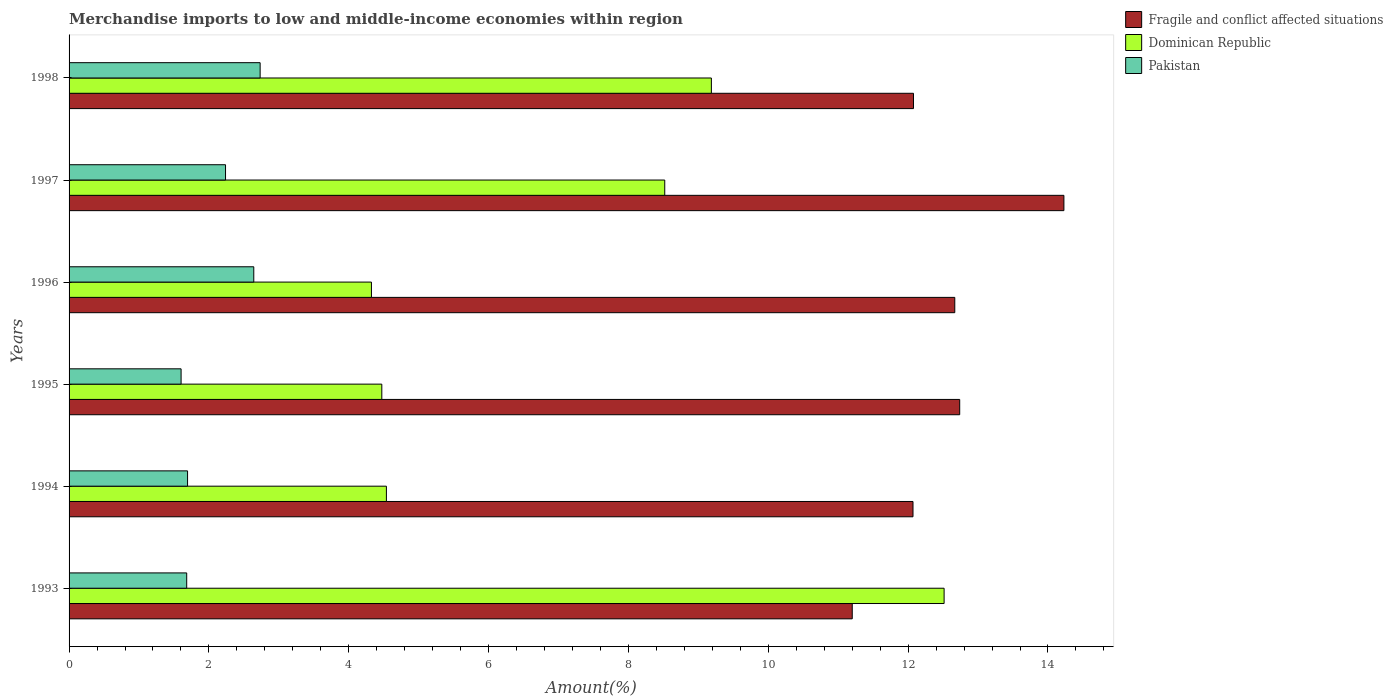How many different coloured bars are there?
Your answer should be very brief. 3. How many groups of bars are there?
Ensure brevity in your answer.  6. Are the number of bars per tick equal to the number of legend labels?
Ensure brevity in your answer.  Yes. Are the number of bars on each tick of the Y-axis equal?
Ensure brevity in your answer.  Yes. What is the percentage of amount earned from merchandise imports in Pakistan in 1993?
Your response must be concise. 1.68. Across all years, what is the maximum percentage of amount earned from merchandise imports in Pakistan?
Offer a terse response. 2.73. Across all years, what is the minimum percentage of amount earned from merchandise imports in Dominican Republic?
Ensure brevity in your answer.  4.32. In which year was the percentage of amount earned from merchandise imports in Fragile and conflict affected situations maximum?
Make the answer very short. 1997. What is the total percentage of amount earned from merchandise imports in Dominican Republic in the graph?
Your answer should be very brief. 43.56. What is the difference between the percentage of amount earned from merchandise imports in Dominican Republic in 1994 and that in 1995?
Provide a succinct answer. 0.07. What is the difference between the percentage of amount earned from merchandise imports in Dominican Republic in 1995 and the percentage of amount earned from merchandise imports in Pakistan in 1997?
Keep it short and to the point. 2.23. What is the average percentage of amount earned from merchandise imports in Fragile and conflict affected situations per year?
Offer a very short reply. 12.5. In the year 1998, what is the difference between the percentage of amount earned from merchandise imports in Dominican Republic and percentage of amount earned from merchandise imports in Fragile and conflict affected situations?
Offer a very short reply. -2.89. What is the ratio of the percentage of amount earned from merchandise imports in Dominican Republic in 1995 to that in 1996?
Provide a short and direct response. 1.03. Is the percentage of amount earned from merchandise imports in Dominican Republic in 1993 less than that in 1996?
Your answer should be very brief. No. Is the difference between the percentage of amount earned from merchandise imports in Dominican Republic in 1993 and 1995 greater than the difference between the percentage of amount earned from merchandise imports in Fragile and conflict affected situations in 1993 and 1995?
Offer a terse response. Yes. What is the difference between the highest and the second highest percentage of amount earned from merchandise imports in Dominican Republic?
Keep it short and to the point. 3.33. What is the difference between the highest and the lowest percentage of amount earned from merchandise imports in Fragile and conflict affected situations?
Your answer should be compact. 3.03. Is the sum of the percentage of amount earned from merchandise imports in Fragile and conflict affected situations in 1994 and 1995 greater than the maximum percentage of amount earned from merchandise imports in Pakistan across all years?
Make the answer very short. Yes. What does the 3rd bar from the top in 1994 represents?
Your answer should be compact. Fragile and conflict affected situations. What does the 3rd bar from the bottom in 1997 represents?
Provide a succinct answer. Pakistan. Are all the bars in the graph horizontal?
Give a very brief answer. Yes. What is the difference between two consecutive major ticks on the X-axis?
Your answer should be very brief. 2. Are the values on the major ticks of X-axis written in scientific E-notation?
Ensure brevity in your answer.  No. Does the graph contain grids?
Offer a terse response. No. Where does the legend appear in the graph?
Keep it short and to the point. Top right. How many legend labels are there?
Ensure brevity in your answer.  3. What is the title of the graph?
Keep it short and to the point. Merchandise imports to low and middle-income economies within region. What is the label or title of the X-axis?
Provide a short and direct response. Amount(%). What is the Amount(%) of Fragile and conflict affected situations in 1993?
Provide a succinct answer. 11.2. What is the Amount(%) of Dominican Republic in 1993?
Make the answer very short. 12.51. What is the Amount(%) in Pakistan in 1993?
Provide a succinct answer. 1.68. What is the Amount(%) of Fragile and conflict affected situations in 1994?
Your answer should be compact. 12.07. What is the Amount(%) of Dominican Republic in 1994?
Provide a succinct answer. 4.54. What is the Amount(%) of Pakistan in 1994?
Give a very brief answer. 1.69. What is the Amount(%) in Fragile and conflict affected situations in 1995?
Your response must be concise. 12.74. What is the Amount(%) of Dominican Republic in 1995?
Your answer should be compact. 4.47. What is the Amount(%) in Pakistan in 1995?
Give a very brief answer. 1.6. What is the Amount(%) in Fragile and conflict affected situations in 1996?
Provide a succinct answer. 12.67. What is the Amount(%) of Dominican Republic in 1996?
Offer a terse response. 4.32. What is the Amount(%) in Pakistan in 1996?
Give a very brief answer. 2.64. What is the Amount(%) in Fragile and conflict affected situations in 1997?
Offer a terse response. 14.23. What is the Amount(%) of Dominican Republic in 1997?
Your response must be concise. 8.52. What is the Amount(%) of Pakistan in 1997?
Offer a very short reply. 2.24. What is the Amount(%) in Fragile and conflict affected situations in 1998?
Your answer should be very brief. 12.08. What is the Amount(%) of Dominican Republic in 1998?
Ensure brevity in your answer.  9.19. What is the Amount(%) of Pakistan in 1998?
Provide a succinct answer. 2.73. Across all years, what is the maximum Amount(%) in Fragile and conflict affected situations?
Provide a succinct answer. 14.23. Across all years, what is the maximum Amount(%) of Dominican Republic?
Your response must be concise. 12.51. Across all years, what is the maximum Amount(%) in Pakistan?
Give a very brief answer. 2.73. Across all years, what is the minimum Amount(%) in Fragile and conflict affected situations?
Provide a succinct answer. 11.2. Across all years, what is the minimum Amount(%) in Dominican Republic?
Your response must be concise. 4.32. Across all years, what is the minimum Amount(%) of Pakistan?
Provide a succinct answer. 1.6. What is the total Amount(%) of Fragile and conflict affected situations in the graph?
Offer a terse response. 74.98. What is the total Amount(%) of Dominican Republic in the graph?
Provide a short and direct response. 43.56. What is the total Amount(%) in Pakistan in the graph?
Your answer should be very brief. 12.59. What is the difference between the Amount(%) in Fragile and conflict affected situations in 1993 and that in 1994?
Your response must be concise. -0.87. What is the difference between the Amount(%) of Dominican Republic in 1993 and that in 1994?
Offer a very short reply. 7.98. What is the difference between the Amount(%) in Pakistan in 1993 and that in 1994?
Your answer should be very brief. -0.01. What is the difference between the Amount(%) of Fragile and conflict affected situations in 1993 and that in 1995?
Offer a very short reply. -1.54. What is the difference between the Amount(%) in Dominican Republic in 1993 and that in 1995?
Your answer should be very brief. 8.04. What is the difference between the Amount(%) in Pakistan in 1993 and that in 1995?
Your answer should be very brief. 0.08. What is the difference between the Amount(%) in Fragile and conflict affected situations in 1993 and that in 1996?
Provide a short and direct response. -1.47. What is the difference between the Amount(%) of Dominican Republic in 1993 and that in 1996?
Provide a succinct answer. 8.19. What is the difference between the Amount(%) in Pakistan in 1993 and that in 1996?
Your response must be concise. -0.96. What is the difference between the Amount(%) of Fragile and conflict affected situations in 1993 and that in 1997?
Keep it short and to the point. -3.03. What is the difference between the Amount(%) of Dominican Republic in 1993 and that in 1997?
Give a very brief answer. 4. What is the difference between the Amount(%) in Pakistan in 1993 and that in 1997?
Offer a very short reply. -0.56. What is the difference between the Amount(%) of Fragile and conflict affected situations in 1993 and that in 1998?
Keep it short and to the point. -0.88. What is the difference between the Amount(%) of Dominican Republic in 1993 and that in 1998?
Ensure brevity in your answer.  3.33. What is the difference between the Amount(%) of Pakistan in 1993 and that in 1998?
Provide a short and direct response. -1.05. What is the difference between the Amount(%) of Fragile and conflict affected situations in 1994 and that in 1995?
Provide a short and direct response. -0.67. What is the difference between the Amount(%) in Dominican Republic in 1994 and that in 1995?
Provide a succinct answer. 0.07. What is the difference between the Amount(%) in Pakistan in 1994 and that in 1995?
Give a very brief answer. 0.09. What is the difference between the Amount(%) of Fragile and conflict affected situations in 1994 and that in 1996?
Offer a terse response. -0.6. What is the difference between the Amount(%) of Dominican Republic in 1994 and that in 1996?
Give a very brief answer. 0.21. What is the difference between the Amount(%) in Pakistan in 1994 and that in 1996?
Your answer should be compact. -0.95. What is the difference between the Amount(%) of Fragile and conflict affected situations in 1994 and that in 1997?
Offer a terse response. -2.16. What is the difference between the Amount(%) in Dominican Republic in 1994 and that in 1997?
Your answer should be very brief. -3.98. What is the difference between the Amount(%) in Pakistan in 1994 and that in 1997?
Offer a terse response. -0.54. What is the difference between the Amount(%) of Fragile and conflict affected situations in 1994 and that in 1998?
Offer a terse response. -0.01. What is the difference between the Amount(%) in Dominican Republic in 1994 and that in 1998?
Offer a very short reply. -4.65. What is the difference between the Amount(%) in Pakistan in 1994 and that in 1998?
Keep it short and to the point. -1.04. What is the difference between the Amount(%) in Fragile and conflict affected situations in 1995 and that in 1996?
Provide a short and direct response. 0.07. What is the difference between the Amount(%) of Dominican Republic in 1995 and that in 1996?
Your answer should be very brief. 0.15. What is the difference between the Amount(%) of Pakistan in 1995 and that in 1996?
Offer a terse response. -1.04. What is the difference between the Amount(%) of Fragile and conflict affected situations in 1995 and that in 1997?
Provide a short and direct response. -1.49. What is the difference between the Amount(%) of Dominican Republic in 1995 and that in 1997?
Offer a very short reply. -4.05. What is the difference between the Amount(%) in Pakistan in 1995 and that in 1997?
Provide a short and direct response. -0.64. What is the difference between the Amount(%) of Fragile and conflict affected situations in 1995 and that in 1998?
Your answer should be compact. 0.66. What is the difference between the Amount(%) of Dominican Republic in 1995 and that in 1998?
Make the answer very short. -4.71. What is the difference between the Amount(%) in Pakistan in 1995 and that in 1998?
Keep it short and to the point. -1.13. What is the difference between the Amount(%) of Fragile and conflict affected situations in 1996 and that in 1997?
Your response must be concise. -1.56. What is the difference between the Amount(%) of Dominican Republic in 1996 and that in 1997?
Offer a terse response. -4.19. What is the difference between the Amount(%) in Pakistan in 1996 and that in 1997?
Your response must be concise. 0.4. What is the difference between the Amount(%) in Fragile and conflict affected situations in 1996 and that in 1998?
Your answer should be compact. 0.59. What is the difference between the Amount(%) of Dominican Republic in 1996 and that in 1998?
Your response must be concise. -4.86. What is the difference between the Amount(%) in Pakistan in 1996 and that in 1998?
Provide a succinct answer. -0.09. What is the difference between the Amount(%) in Fragile and conflict affected situations in 1997 and that in 1998?
Keep it short and to the point. 2.15. What is the difference between the Amount(%) of Dominican Republic in 1997 and that in 1998?
Keep it short and to the point. -0.67. What is the difference between the Amount(%) in Pakistan in 1997 and that in 1998?
Provide a short and direct response. -0.49. What is the difference between the Amount(%) in Fragile and conflict affected situations in 1993 and the Amount(%) in Dominican Republic in 1994?
Your response must be concise. 6.66. What is the difference between the Amount(%) in Fragile and conflict affected situations in 1993 and the Amount(%) in Pakistan in 1994?
Your answer should be very brief. 9.51. What is the difference between the Amount(%) in Dominican Republic in 1993 and the Amount(%) in Pakistan in 1994?
Your answer should be very brief. 10.82. What is the difference between the Amount(%) of Fragile and conflict affected situations in 1993 and the Amount(%) of Dominican Republic in 1995?
Your answer should be compact. 6.73. What is the difference between the Amount(%) of Fragile and conflict affected situations in 1993 and the Amount(%) of Pakistan in 1995?
Your response must be concise. 9.6. What is the difference between the Amount(%) of Dominican Republic in 1993 and the Amount(%) of Pakistan in 1995?
Your answer should be compact. 10.91. What is the difference between the Amount(%) in Fragile and conflict affected situations in 1993 and the Amount(%) in Dominican Republic in 1996?
Provide a succinct answer. 6.88. What is the difference between the Amount(%) in Fragile and conflict affected situations in 1993 and the Amount(%) in Pakistan in 1996?
Offer a very short reply. 8.56. What is the difference between the Amount(%) in Dominican Republic in 1993 and the Amount(%) in Pakistan in 1996?
Offer a terse response. 9.87. What is the difference between the Amount(%) of Fragile and conflict affected situations in 1993 and the Amount(%) of Dominican Republic in 1997?
Your response must be concise. 2.68. What is the difference between the Amount(%) in Fragile and conflict affected situations in 1993 and the Amount(%) in Pakistan in 1997?
Ensure brevity in your answer.  8.96. What is the difference between the Amount(%) in Dominican Republic in 1993 and the Amount(%) in Pakistan in 1997?
Offer a very short reply. 10.28. What is the difference between the Amount(%) in Fragile and conflict affected situations in 1993 and the Amount(%) in Dominican Republic in 1998?
Ensure brevity in your answer.  2.01. What is the difference between the Amount(%) of Fragile and conflict affected situations in 1993 and the Amount(%) of Pakistan in 1998?
Make the answer very short. 8.47. What is the difference between the Amount(%) in Dominican Republic in 1993 and the Amount(%) in Pakistan in 1998?
Your answer should be very brief. 9.78. What is the difference between the Amount(%) in Fragile and conflict affected situations in 1994 and the Amount(%) in Dominican Republic in 1995?
Offer a terse response. 7.6. What is the difference between the Amount(%) of Fragile and conflict affected situations in 1994 and the Amount(%) of Pakistan in 1995?
Your answer should be very brief. 10.47. What is the difference between the Amount(%) of Dominican Republic in 1994 and the Amount(%) of Pakistan in 1995?
Provide a short and direct response. 2.94. What is the difference between the Amount(%) of Fragile and conflict affected situations in 1994 and the Amount(%) of Dominican Republic in 1996?
Ensure brevity in your answer.  7.75. What is the difference between the Amount(%) of Fragile and conflict affected situations in 1994 and the Amount(%) of Pakistan in 1996?
Your answer should be very brief. 9.43. What is the difference between the Amount(%) of Dominican Republic in 1994 and the Amount(%) of Pakistan in 1996?
Make the answer very short. 1.9. What is the difference between the Amount(%) of Fragile and conflict affected situations in 1994 and the Amount(%) of Dominican Republic in 1997?
Ensure brevity in your answer.  3.55. What is the difference between the Amount(%) in Fragile and conflict affected situations in 1994 and the Amount(%) in Pakistan in 1997?
Give a very brief answer. 9.83. What is the difference between the Amount(%) of Dominican Republic in 1994 and the Amount(%) of Pakistan in 1997?
Provide a short and direct response. 2.3. What is the difference between the Amount(%) of Fragile and conflict affected situations in 1994 and the Amount(%) of Dominican Republic in 1998?
Offer a terse response. 2.88. What is the difference between the Amount(%) of Fragile and conflict affected situations in 1994 and the Amount(%) of Pakistan in 1998?
Offer a terse response. 9.34. What is the difference between the Amount(%) in Dominican Republic in 1994 and the Amount(%) in Pakistan in 1998?
Your answer should be compact. 1.81. What is the difference between the Amount(%) of Fragile and conflict affected situations in 1995 and the Amount(%) of Dominican Republic in 1996?
Your answer should be very brief. 8.41. What is the difference between the Amount(%) in Fragile and conflict affected situations in 1995 and the Amount(%) in Pakistan in 1996?
Ensure brevity in your answer.  10.1. What is the difference between the Amount(%) in Dominican Republic in 1995 and the Amount(%) in Pakistan in 1996?
Your answer should be compact. 1.83. What is the difference between the Amount(%) of Fragile and conflict affected situations in 1995 and the Amount(%) of Dominican Republic in 1997?
Offer a very short reply. 4.22. What is the difference between the Amount(%) in Fragile and conflict affected situations in 1995 and the Amount(%) in Pakistan in 1997?
Your response must be concise. 10.5. What is the difference between the Amount(%) in Dominican Republic in 1995 and the Amount(%) in Pakistan in 1997?
Offer a very short reply. 2.23. What is the difference between the Amount(%) in Fragile and conflict affected situations in 1995 and the Amount(%) in Dominican Republic in 1998?
Make the answer very short. 3.55. What is the difference between the Amount(%) in Fragile and conflict affected situations in 1995 and the Amount(%) in Pakistan in 1998?
Keep it short and to the point. 10. What is the difference between the Amount(%) in Dominican Republic in 1995 and the Amount(%) in Pakistan in 1998?
Offer a very short reply. 1.74. What is the difference between the Amount(%) in Fragile and conflict affected situations in 1996 and the Amount(%) in Dominican Republic in 1997?
Your response must be concise. 4.15. What is the difference between the Amount(%) in Fragile and conflict affected situations in 1996 and the Amount(%) in Pakistan in 1997?
Your response must be concise. 10.43. What is the difference between the Amount(%) of Dominican Republic in 1996 and the Amount(%) of Pakistan in 1997?
Provide a succinct answer. 2.09. What is the difference between the Amount(%) in Fragile and conflict affected situations in 1996 and the Amount(%) in Dominican Republic in 1998?
Give a very brief answer. 3.48. What is the difference between the Amount(%) in Fragile and conflict affected situations in 1996 and the Amount(%) in Pakistan in 1998?
Offer a very short reply. 9.93. What is the difference between the Amount(%) in Dominican Republic in 1996 and the Amount(%) in Pakistan in 1998?
Provide a short and direct response. 1.59. What is the difference between the Amount(%) of Fragile and conflict affected situations in 1997 and the Amount(%) of Dominican Republic in 1998?
Your answer should be compact. 5.04. What is the difference between the Amount(%) of Fragile and conflict affected situations in 1997 and the Amount(%) of Pakistan in 1998?
Ensure brevity in your answer.  11.5. What is the difference between the Amount(%) in Dominican Republic in 1997 and the Amount(%) in Pakistan in 1998?
Make the answer very short. 5.79. What is the average Amount(%) in Fragile and conflict affected situations per year?
Provide a succinct answer. 12.5. What is the average Amount(%) in Dominican Republic per year?
Your answer should be very brief. 7.26. What is the average Amount(%) in Pakistan per year?
Offer a very short reply. 2.1. In the year 1993, what is the difference between the Amount(%) of Fragile and conflict affected situations and Amount(%) of Dominican Republic?
Keep it short and to the point. -1.31. In the year 1993, what is the difference between the Amount(%) in Fragile and conflict affected situations and Amount(%) in Pakistan?
Ensure brevity in your answer.  9.52. In the year 1993, what is the difference between the Amount(%) of Dominican Republic and Amount(%) of Pakistan?
Offer a terse response. 10.83. In the year 1994, what is the difference between the Amount(%) in Fragile and conflict affected situations and Amount(%) in Dominican Republic?
Your answer should be compact. 7.53. In the year 1994, what is the difference between the Amount(%) of Fragile and conflict affected situations and Amount(%) of Pakistan?
Offer a terse response. 10.37. In the year 1994, what is the difference between the Amount(%) in Dominican Republic and Amount(%) in Pakistan?
Offer a terse response. 2.84. In the year 1995, what is the difference between the Amount(%) in Fragile and conflict affected situations and Amount(%) in Dominican Republic?
Your answer should be compact. 8.26. In the year 1995, what is the difference between the Amount(%) in Fragile and conflict affected situations and Amount(%) in Pakistan?
Ensure brevity in your answer.  11.14. In the year 1995, what is the difference between the Amount(%) of Dominican Republic and Amount(%) of Pakistan?
Your response must be concise. 2.87. In the year 1996, what is the difference between the Amount(%) in Fragile and conflict affected situations and Amount(%) in Dominican Republic?
Keep it short and to the point. 8.34. In the year 1996, what is the difference between the Amount(%) of Fragile and conflict affected situations and Amount(%) of Pakistan?
Your answer should be compact. 10.03. In the year 1996, what is the difference between the Amount(%) in Dominican Republic and Amount(%) in Pakistan?
Offer a terse response. 1.68. In the year 1997, what is the difference between the Amount(%) in Fragile and conflict affected situations and Amount(%) in Dominican Republic?
Offer a very short reply. 5.71. In the year 1997, what is the difference between the Amount(%) of Fragile and conflict affected situations and Amount(%) of Pakistan?
Offer a terse response. 11.99. In the year 1997, what is the difference between the Amount(%) of Dominican Republic and Amount(%) of Pakistan?
Make the answer very short. 6.28. In the year 1998, what is the difference between the Amount(%) of Fragile and conflict affected situations and Amount(%) of Dominican Republic?
Ensure brevity in your answer.  2.89. In the year 1998, what is the difference between the Amount(%) in Fragile and conflict affected situations and Amount(%) in Pakistan?
Your response must be concise. 9.34. In the year 1998, what is the difference between the Amount(%) of Dominican Republic and Amount(%) of Pakistan?
Offer a terse response. 6.45. What is the ratio of the Amount(%) of Fragile and conflict affected situations in 1993 to that in 1994?
Make the answer very short. 0.93. What is the ratio of the Amount(%) of Dominican Republic in 1993 to that in 1994?
Provide a short and direct response. 2.76. What is the ratio of the Amount(%) of Pakistan in 1993 to that in 1994?
Provide a succinct answer. 0.99. What is the ratio of the Amount(%) in Fragile and conflict affected situations in 1993 to that in 1995?
Provide a short and direct response. 0.88. What is the ratio of the Amount(%) in Dominican Republic in 1993 to that in 1995?
Your answer should be compact. 2.8. What is the ratio of the Amount(%) in Fragile and conflict affected situations in 1993 to that in 1996?
Give a very brief answer. 0.88. What is the ratio of the Amount(%) in Dominican Republic in 1993 to that in 1996?
Offer a very short reply. 2.89. What is the ratio of the Amount(%) of Pakistan in 1993 to that in 1996?
Ensure brevity in your answer.  0.64. What is the ratio of the Amount(%) in Fragile and conflict affected situations in 1993 to that in 1997?
Make the answer very short. 0.79. What is the ratio of the Amount(%) of Dominican Republic in 1993 to that in 1997?
Your response must be concise. 1.47. What is the ratio of the Amount(%) of Pakistan in 1993 to that in 1997?
Give a very brief answer. 0.75. What is the ratio of the Amount(%) of Fragile and conflict affected situations in 1993 to that in 1998?
Your response must be concise. 0.93. What is the ratio of the Amount(%) in Dominican Republic in 1993 to that in 1998?
Your answer should be compact. 1.36. What is the ratio of the Amount(%) of Pakistan in 1993 to that in 1998?
Give a very brief answer. 0.62. What is the ratio of the Amount(%) in Fragile and conflict affected situations in 1994 to that in 1995?
Offer a terse response. 0.95. What is the ratio of the Amount(%) of Dominican Republic in 1994 to that in 1995?
Your answer should be very brief. 1.01. What is the ratio of the Amount(%) of Pakistan in 1994 to that in 1995?
Provide a short and direct response. 1.06. What is the ratio of the Amount(%) in Fragile and conflict affected situations in 1994 to that in 1996?
Make the answer very short. 0.95. What is the ratio of the Amount(%) in Dominican Republic in 1994 to that in 1996?
Provide a short and direct response. 1.05. What is the ratio of the Amount(%) of Pakistan in 1994 to that in 1996?
Your answer should be very brief. 0.64. What is the ratio of the Amount(%) in Fragile and conflict affected situations in 1994 to that in 1997?
Your response must be concise. 0.85. What is the ratio of the Amount(%) in Dominican Republic in 1994 to that in 1997?
Make the answer very short. 0.53. What is the ratio of the Amount(%) of Pakistan in 1994 to that in 1997?
Keep it short and to the point. 0.76. What is the ratio of the Amount(%) in Fragile and conflict affected situations in 1994 to that in 1998?
Offer a very short reply. 1. What is the ratio of the Amount(%) of Dominican Republic in 1994 to that in 1998?
Provide a succinct answer. 0.49. What is the ratio of the Amount(%) in Pakistan in 1994 to that in 1998?
Give a very brief answer. 0.62. What is the ratio of the Amount(%) in Fragile and conflict affected situations in 1995 to that in 1996?
Ensure brevity in your answer.  1.01. What is the ratio of the Amount(%) in Dominican Republic in 1995 to that in 1996?
Give a very brief answer. 1.03. What is the ratio of the Amount(%) in Pakistan in 1995 to that in 1996?
Your answer should be compact. 0.61. What is the ratio of the Amount(%) of Fragile and conflict affected situations in 1995 to that in 1997?
Provide a short and direct response. 0.9. What is the ratio of the Amount(%) in Dominican Republic in 1995 to that in 1997?
Provide a succinct answer. 0.53. What is the ratio of the Amount(%) in Pakistan in 1995 to that in 1997?
Offer a terse response. 0.72. What is the ratio of the Amount(%) in Fragile and conflict affected situations in 1995 to that in 1998?
Give a very brief answer. 1.05. What is the ratio of the Amount(%) of Dominican Republic in 1995 to that in 1998?
Give a very brief answer. 0.49. What is the ratio of the Amount(%) in Pakistan in 1995 to that in 1998?
Give a very brief answer. 0.59. What is the ratio of the Amount(%) in Fragile and conflict affected situations in 1996 to that in 1997?
Your answer should be very brief. 0.89. What is the ratio of the Amount(%) in Dominican Republic in 1996 to that in 1997?
Keep it short and to the point. 0.51. What is the ratio of the Amount(%) of Pakistan in 1996 to that in 1997?
Your response must be concise. 1.18. What is the ratio of the Amount(%) in Fragile and conflict affected situations in 1996 to that in 1998?
Your answer should be compact. 1.05. What is the ratio of the Amount(%) in Dominican Republic in 1996 to that in 1998?
Give a very brief answer. 0.47. What is the ratio of the Amount(%) in Pakistan in 1996 to that in 1998?
Provide a succinct answer. 0.97. What is the ratio of the Amount(%) of Fragile and conflict affected situations in 1997 to that in 1998?
Offer a terse response. 1.18. What is the ratio of the Amount(%) in Dominican Republic in 1997 to that in 1998?
Give a very brief answer. 0.93. What is the ratio of the Amount(%) of Pakistan in 1997 to that in 1998?
Ensure brevity in your answer.  0.82. What is the difference between the highest and the second highest Amount(%) of Fragile and conflict affected situations?
Your answer should be compact. 1.49. What is the difference between the highest and the second highest Amount(%) of Dominican Republic?
Ensure brevity in your answer.  3.33. What is the difference between the highest and the second highest Amount(%) of Pakistan?
Ensure brevity in your answer.  0.09. What is the difference between the highest and the lowest Amount(%) of Fragile and conflict affected situations?
Keep it short and to the point. 3.03. What is the difference between the highest and the lowest Amount(%) of Dominican Republic?
Provide a short and direct response. 8.19. What is the difference between the highest and the lowest Amount(%) in Pakistan?
Offer a very short reply. 1.13. 